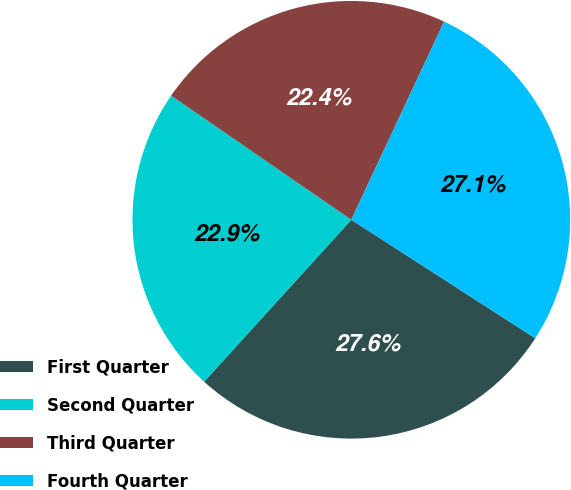Convert chart. <chart><loc_0><loc_0><loc_500><loc_500><pie_chart><fcel>First Quarter<fcel>Second Quarter<fcel>Third Quarter<fcel>Fourth Quarter<nl><fcel>27.63%<fcel>22.86%<fcel>22.37%<fcel>27.14%<nl></chart> 